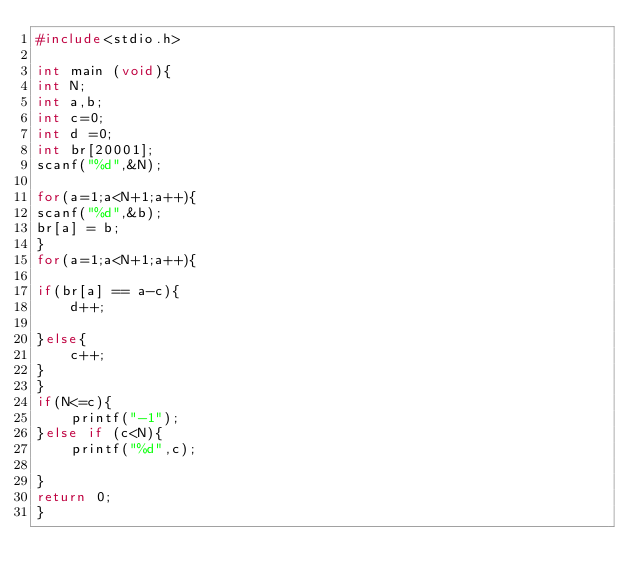Convert code to text. <code><loc_0><loc_0><loc_500><loc_500><_C_>#include<stdio.h>

int main (void){
int N;
int a,b;
int c=0;
int d =0;  
int br[20001];
scanf("%d",&N);

for(a=1;a<N+1;a++){
scanf("%d",&b);
br[a] = b;
}
for(a=1;a<N+1;a++){

if(br[a] == a-c){
    d++;

}else{
    c++;
}
}
if(N<=c){
    printf("-1");
}else if (c<N){
    printf("%d",c);

}
return 0;
}
</code> 